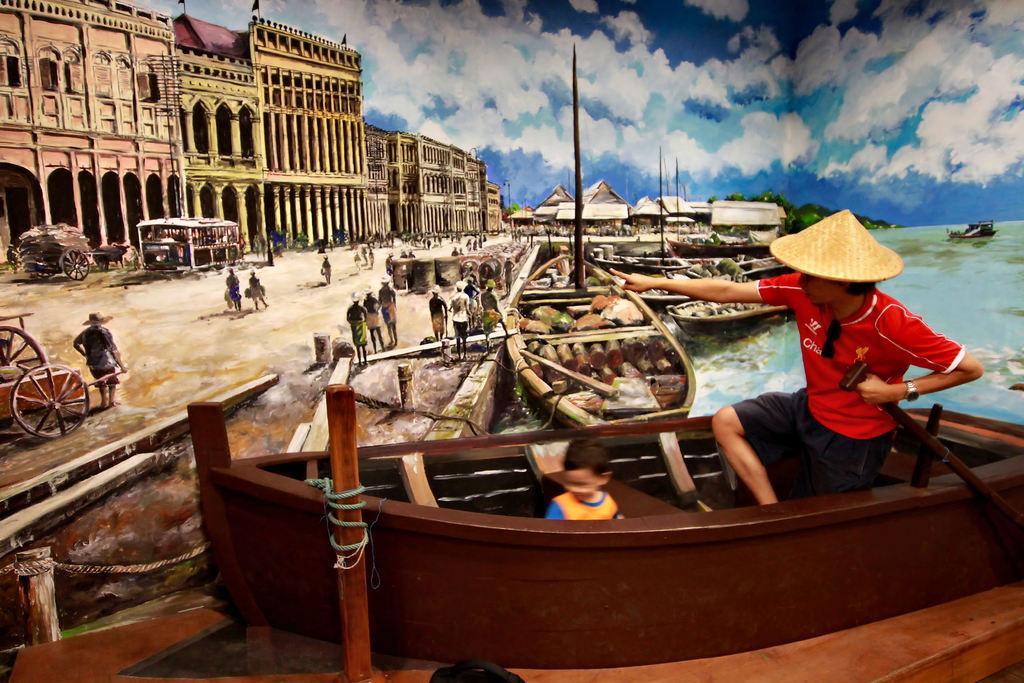Can you describe this image briefly? In this image I can see painting of buildings, boats on water, the sky and people are standing on the ground. Here I can see some objects on the ground. Here I can see a man and a child are in a boat. 